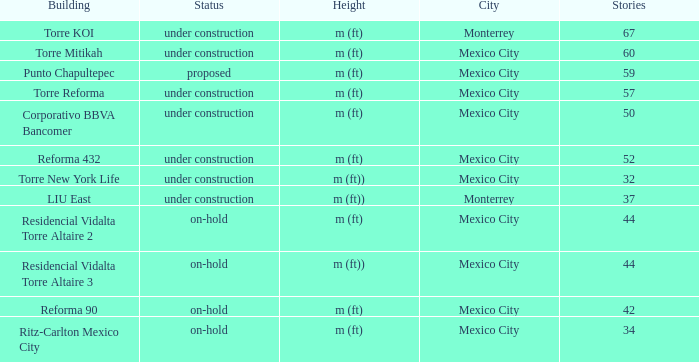How tall is the 52 story building? M (ft). I'm looking to parse the entire table for insights. Could you assist me with that? {'header': ['Building', 'Status', 'Height', 'City', 'Stories'], 'rows': [['Torre KOI', 'under construction', 'm (ft)', 'Monterrey', '67'], ['Torre Mitikah', 'under construction', 'm (ft)', 'Mexico City', '60'], ['Punto Chapultepec', 'proposed', 'm (ft)', 'Mexico City', '59'], ['Torre Reforma', 'under construction', 'm (ft)', 'Mexico City', '57'], ['Corporativo BBVA Bancomer', 'under construction', 'm (ft)', 'Mexico City', '50'], ['Reforma 432', 'under construction', 'm (ft)', 'Mexico City', '52'], ['Torre New York Life', 'under construction', 'm (ft))', 'Mexico City', '32'], ['LIU East', 'under construction', 'm (ft))', 'Monterrey', '37'], ['Residencial Vidalta Torre Altaire 2', 'on-hold', 'm (ft)', 'Mexico City', '44'], ['Residencial Vidalta Torre Altaire 3', 'on-hold', 'm (ft))', 'Mexico City', '44'], ['Reforma 90', 'on-hold', 'm (ft)', 'Mexico City', '42'], ['Ritz-Carlton Mexico City', 'on-hold', 'm (ft)', 'Mexico City', '34']]} 